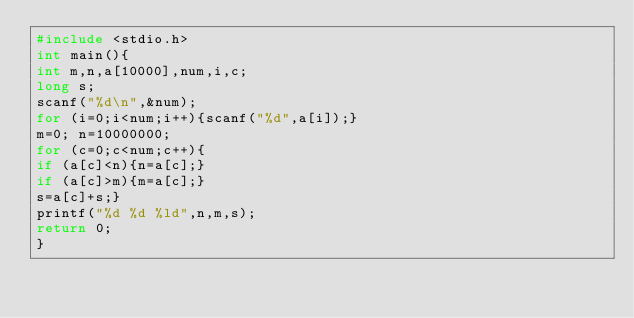Convert code to text. <code><loc_0><loc_0><loc_500><loc_500><_C_>#include <stdio.h>
int main(){
int m,n,a[10000],num,i,c;
long s;
scanf("%d\n",&num);
for (i=0;i<num;i++){scanf("%d",a[i]);}
m=0; n=10000000;
for (c=0;c<num;c++){
if (a[c]<n){n=a[c];}
if (a[c]>m){m=a[c];}
s=a[c]+s;}
printf("%d %d %ld",n,m,s);
return 0;
}</code> 